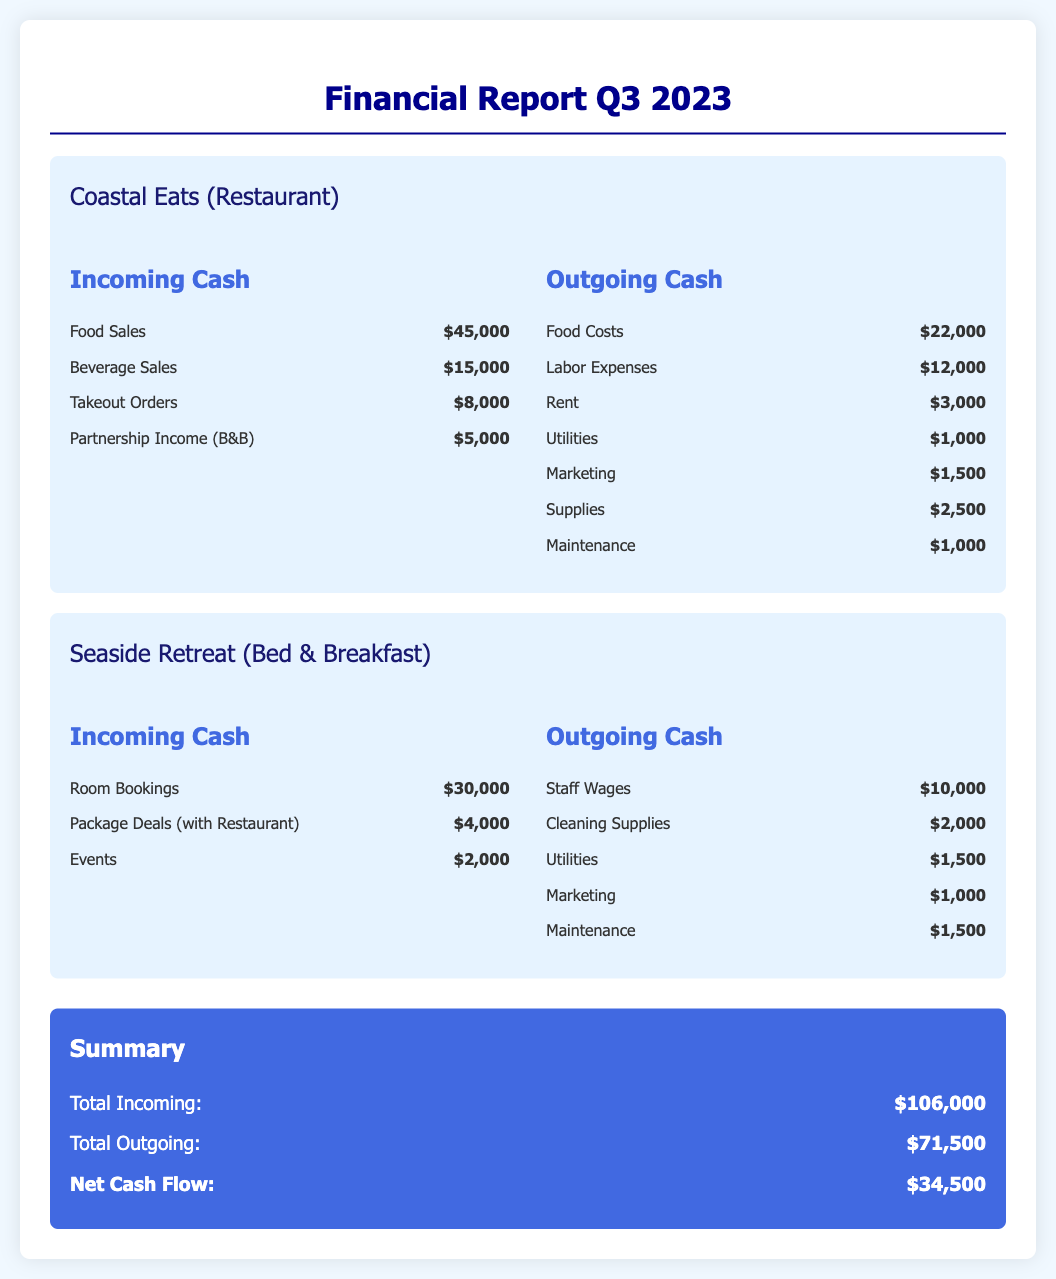what is the total incoming cash for Coastal Eats? The total incoming cash for Coastal Eats is the sum of food sales, beverage sales, takeout orders, and partnership income, which adds up to $45,000 + $15,000 + $8,000 + $5,000 = $73,000.
Answer: $73,000 what are the outgoing cash expenses for Seaside Retreat? The outgoing cash expenses for Seaside Retreat include staff wages, cleaning supplies, utilities, marketing, and maintenance, which totals $10,000 + $2,000 + $1,500 + $1,000 + $1,500 = $16,000.
Answer: $16,000 how much partnership income did Coastal Eats receive from the B&B? The partnership income received by Coastal Eats from the B&B is listed as $5,000 in the incoming cash section.
Answer: $5,000 what is the net cash flow for the quarter? The net cash flow is calculated by subtracting total outgoing cash from total incoming cash, thus $106,000 - $71,500 = $34,500.
Answer: $34,500 which business generated more total incoming cash? By comparing the total incoming cash of Coastal Eats ($73,000) to Seaside Retreat ($36,000), Coastal Eats generated more incoming cash.
Answer: Coastal Eats 